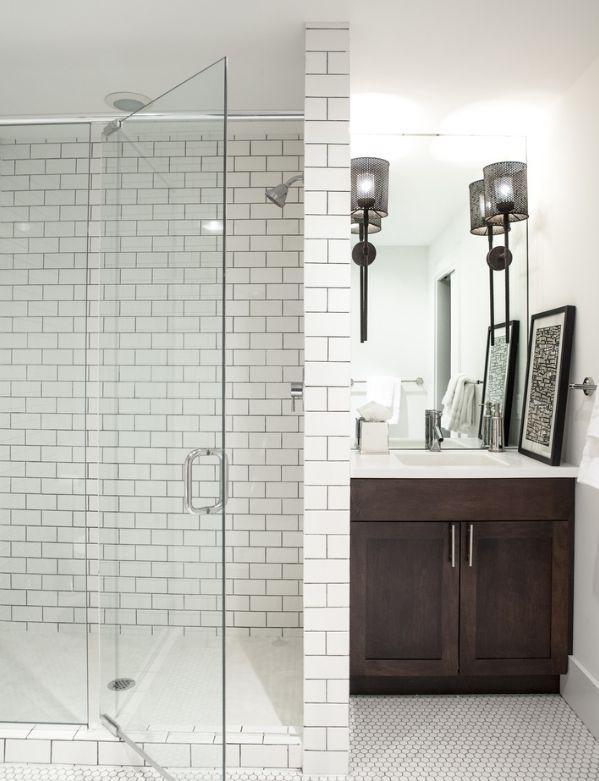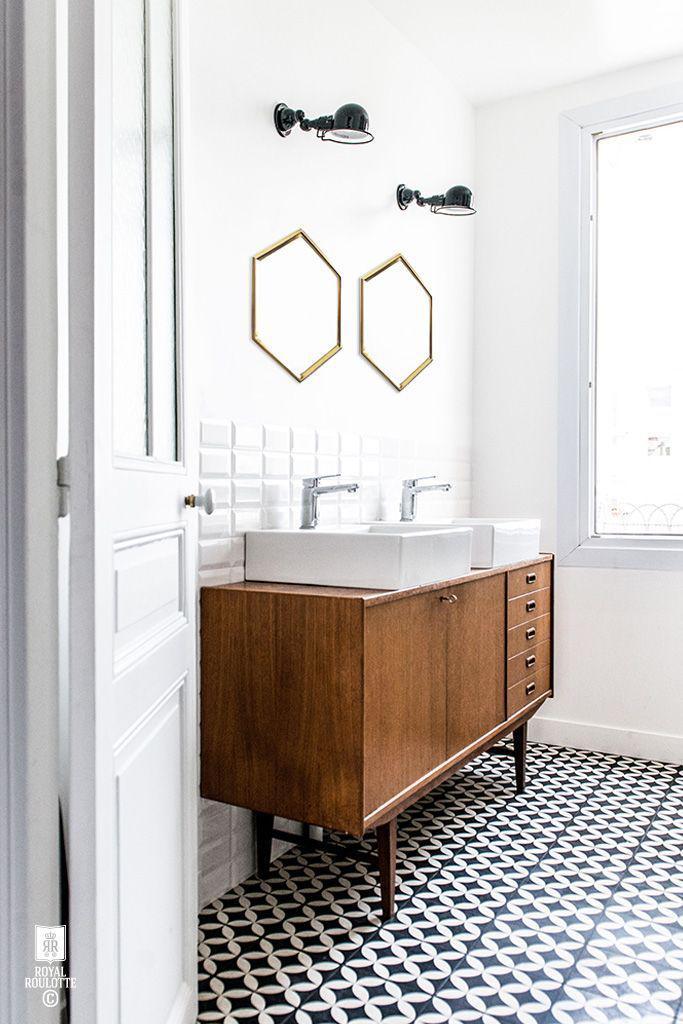The first image is the image on the left, the second image is the image on the right. Given the left and right images, does the statement "In a bathroom with black and white patterned flooring, a wide wooden vanity is topped with one or more white sink fixtures that is backed with at least two rows of white tiles." hold true? Answer yes or no. Yes. The first image is the image on the left, the second image is the image on the right. Evaluate the accuracy of this statement regarding the images: "The bathroom on the right has a black-and-white diamond pattern floor and a long brown sink vanity.". Is it true? Answer yes or no. Yes. 